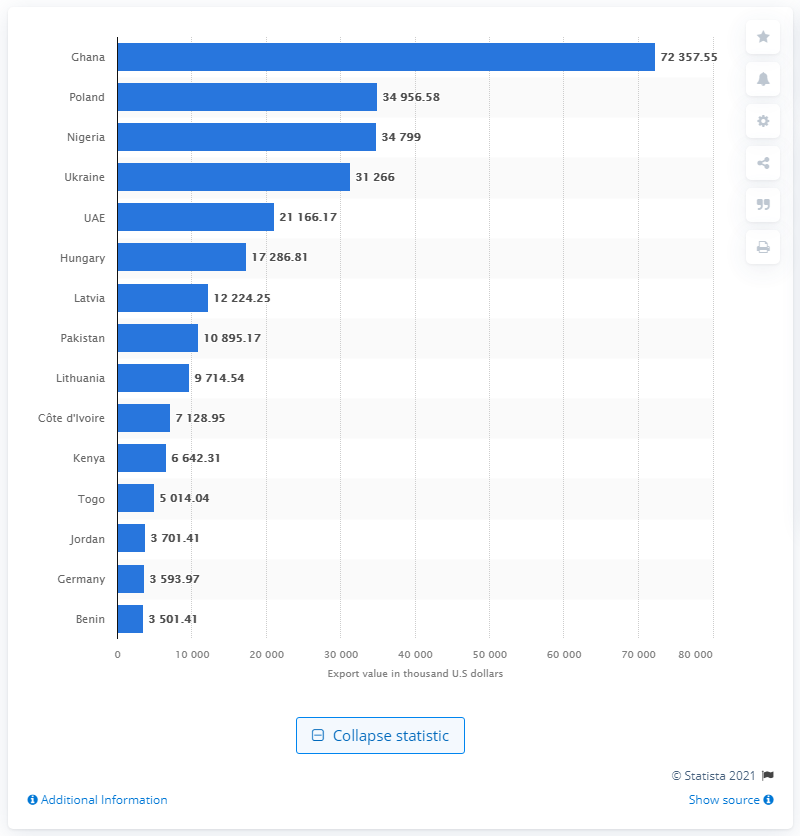Point out several critical features in this image. In 2020, the value of used clothing exported to Ghana was 72,357.55. Exports to Poland were worth nearly 40 million U.S. dollars in 2020, according to recent data. 